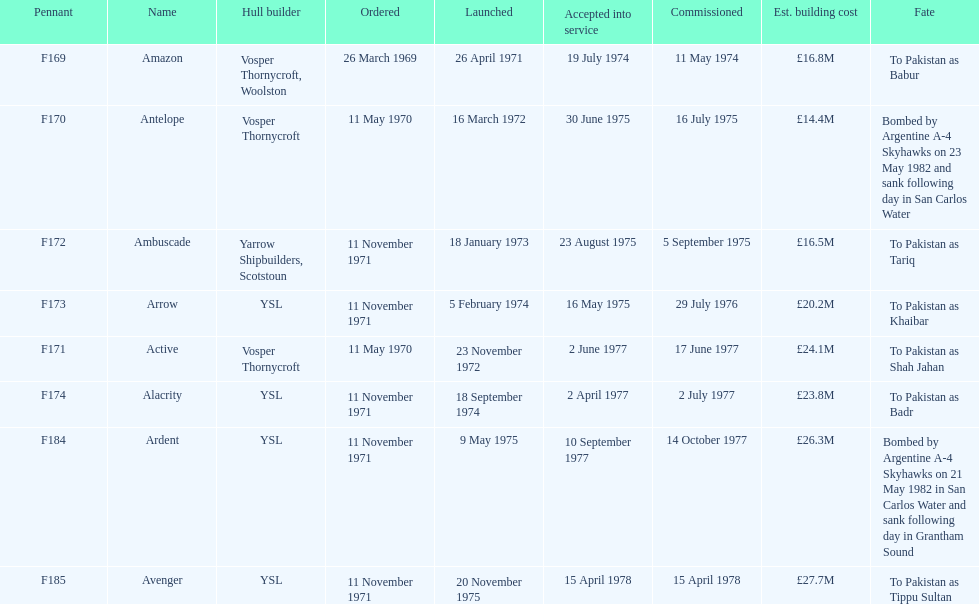The arrow was ordered on november 11, 1971. what was the previous ship? Ambuscade. 